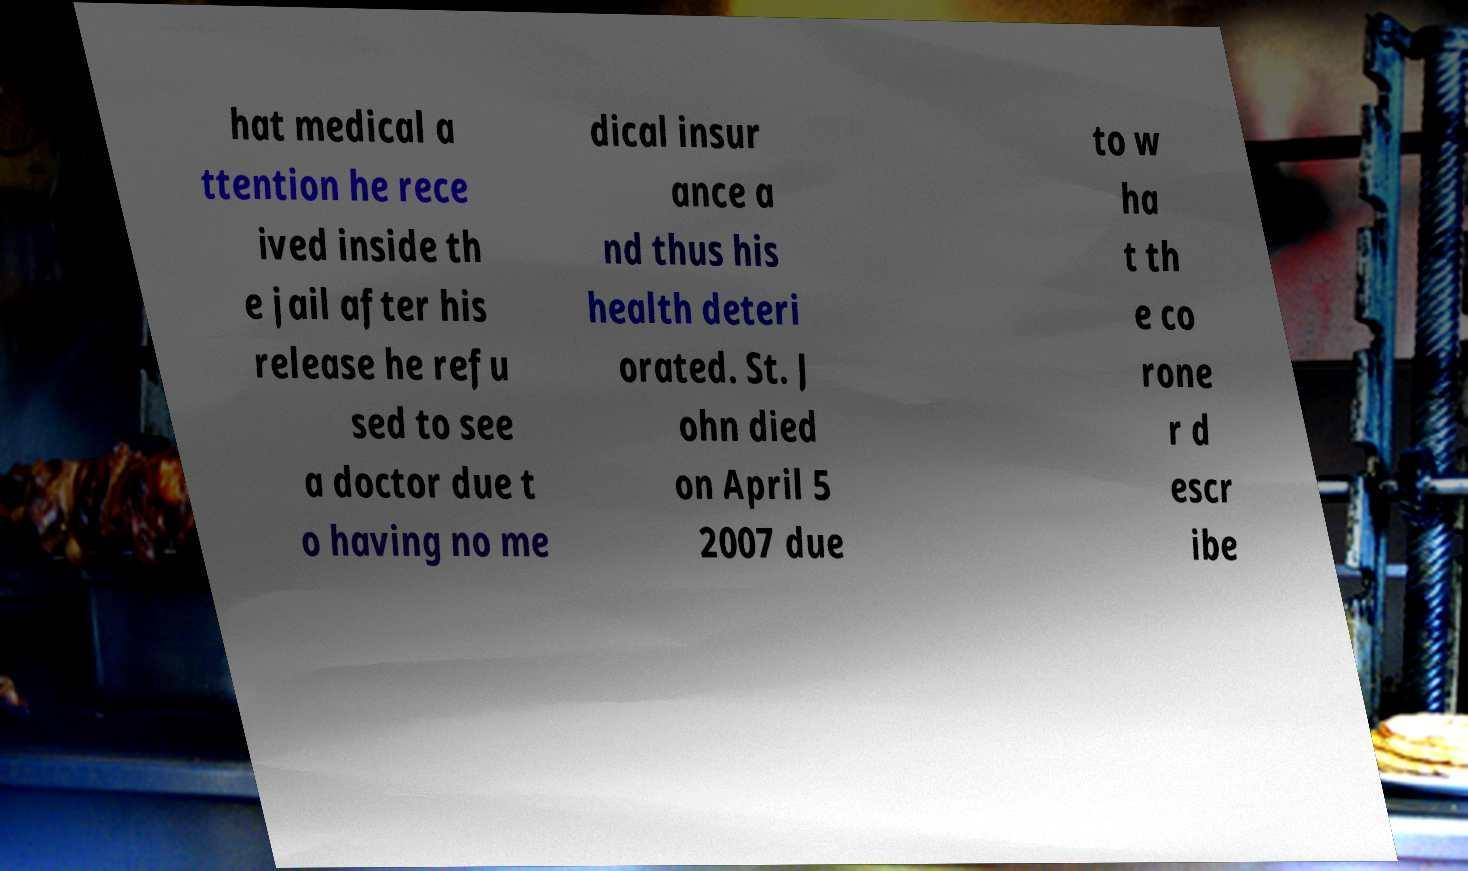I need the written content from this picture converted into text. Can you do that? hat medical a ttention he rece ived inside th e jail after his release he refu sed to see a doctor due t o having no me dical insur ance a nd thus his health deteri orated. St. J ohn died on April 5 2007 due to w ha t th e co rone r d escr ibe 